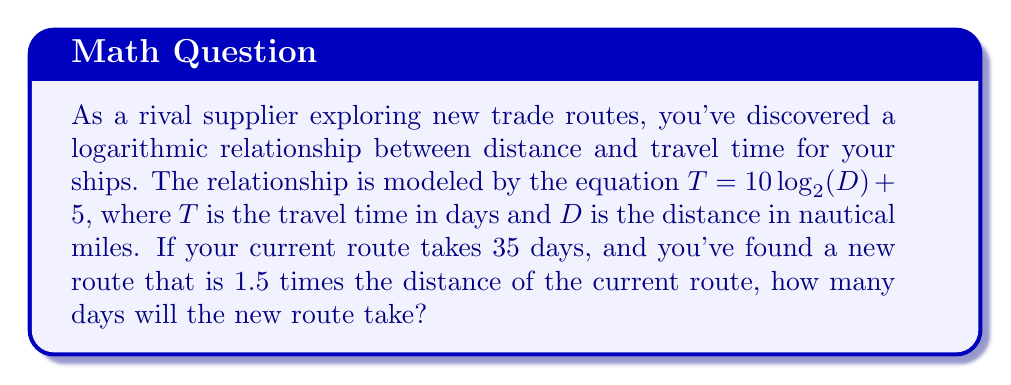Can you solve this math problem? Let's approach this step-by-step:

1) First, we need to find the distance of the current route. We can do this by using the given equation and the current travel time:

   $35 = 10 \log_{2}(D) + 5$

2) Solve for $D$:
   $30 = 10 \log_{2}(D)$
   $3 = \log_{2}(D)$
   $D = 2^3 = 8$ nautical miles

3) Now that we know the current distance, we can calculate the new distance:
   New distance $= 1.5 \times 8 = 12$ nautical miles

4) To find the travel time for the new route, we plug this distance into our original equation:

   $T = 10 \log_{2}(12) + 5$

5) Simplify:
   $T = 10 \log_{2}(2^3 \times 1.5) + 5$
   $T = 10 (\log_{2}(2^3) + \log_{2}(1.5)) + 5$
   $T = 10 (3 + \log_{2}(1.5)) + 5$

6) Calculate $\log_{2}(1.5)$:
   $\log_{2}(1.5) \approx 0.5850$

7) Finish the calculation:
   $T = 10 (3 + 0.5850) + 5$
   $T = 10 (3.5850) + 5$
   $T = 35.85 + 5 = 40.85$

8) Round to the nearest whole number of days:
   $T \approx 41$ days
Answer: The new route will take approximately 41 days. 